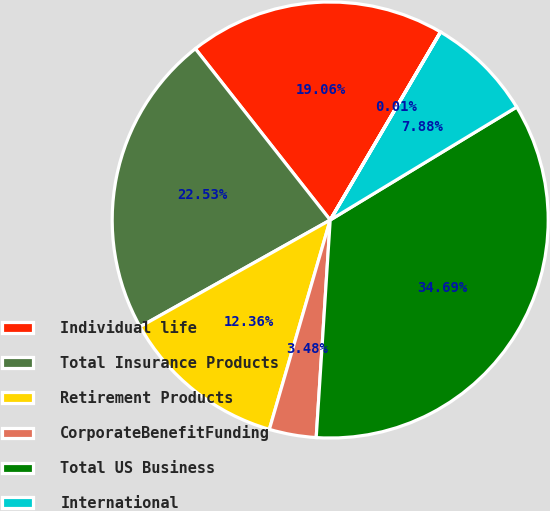<chart> <loc_0><loc_0><loc_500><loc_500><pie_chart><fcel>Individual life<fcel>Total Insurance Products<fcel>Retirement Products<fcel>CorporateBenefitFunding<fcel>Total US Business<fcel>International<fcel>BankingCorporate&Other<nl><fcel>19.06%<fcel>22.53%<fcel>12.36%<fcel>3.48%<fcel>34.7%<fcel>7.88%<fcel>0.01%<nl></chart> 